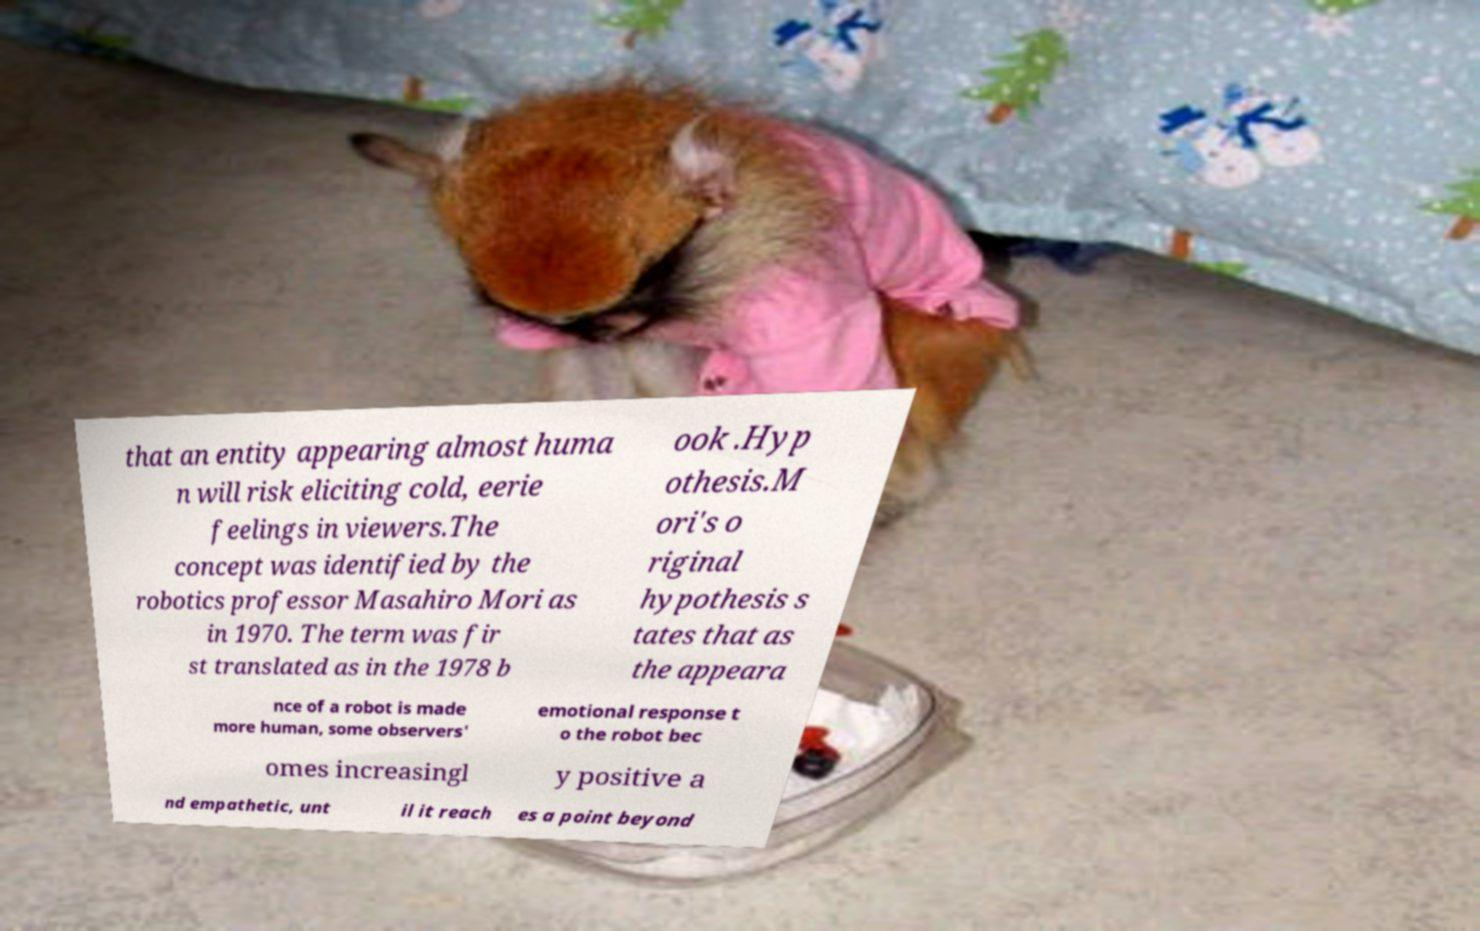Please identify and transcribe the text found in this image. that an entity appearing almost huma n will risk eliciting cold, eerie feelings in viewers.The concept was identified by the robotics professor Masahiro Mori as in 1970. The term was fir st translated as in the 1978 b ook .Hyp othesis.M ori's o riginal hypothesis s tates that as the appeara nce of a robot is made more human, some observers' emotional response t o the robot bec omes increasingl y positive a nd empathetic, unt il it reach es a point beyond 